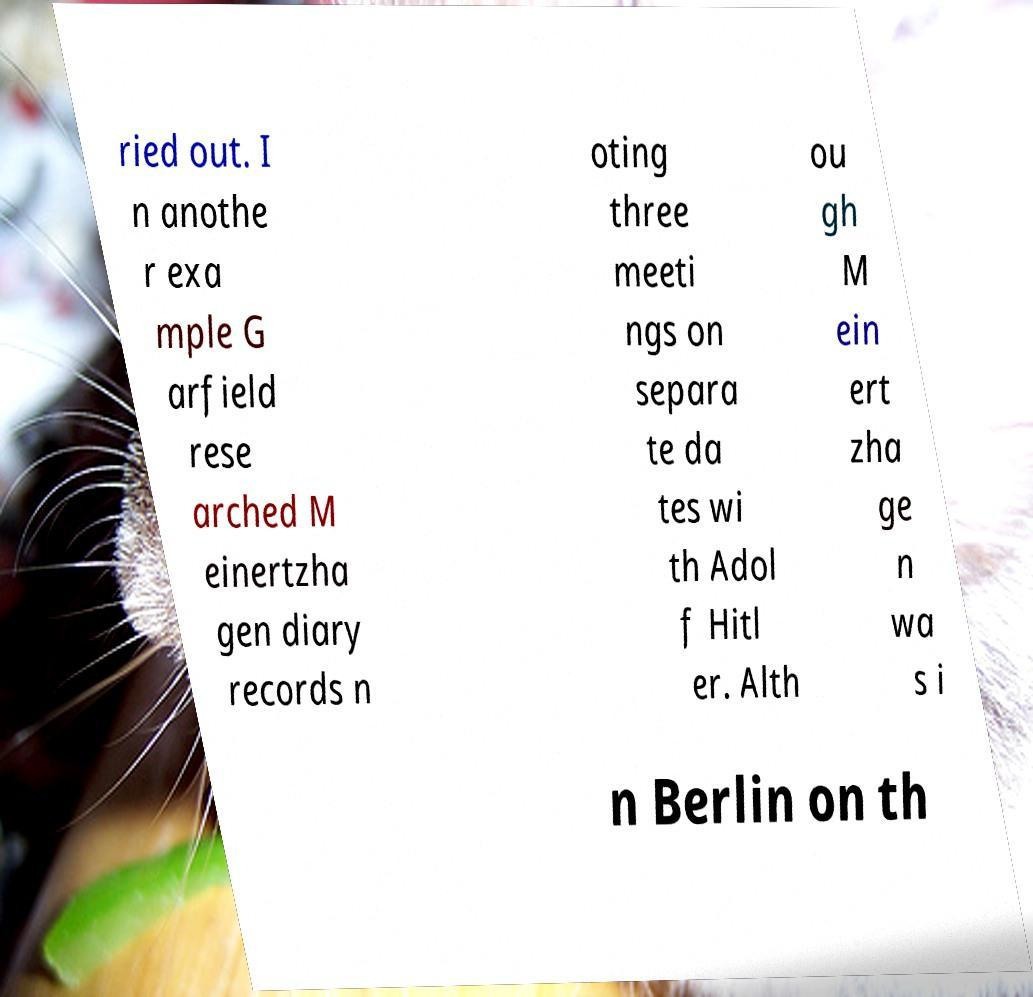For documentation purposes, I need the text within this image transcribed. Could you provide that? ried out. I n anothe r exa mple G arfield rese arched M einertzha gen diary records n oting three meeti ngs on separa te da tes wi th Adol f Hitl er. Alth ou gh M ein ert zha ge n wa s i n Berlin on th 